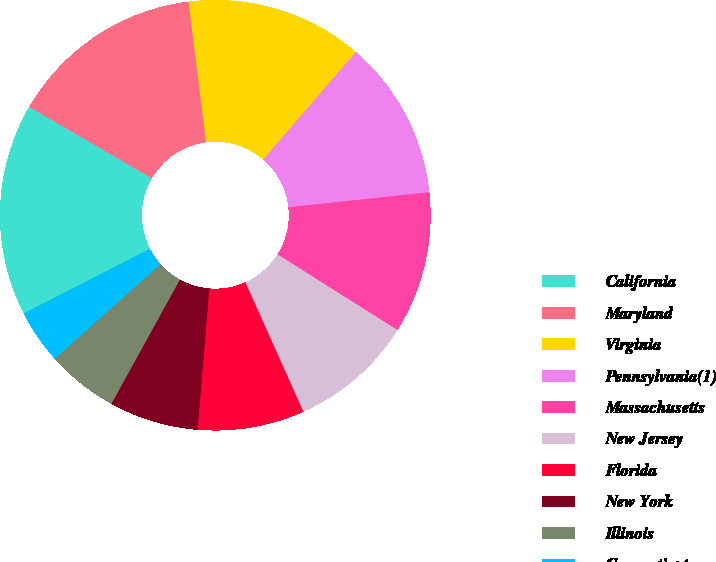<chart> <loc_0><loc_0><loc_500><loc_500><pie_chart><fcel>California<fcel>Maryland<fcel>Virginia<fcel>Pennsylvania(1)<fcel>Massachusetts<fcel>New Jersey<fcel>Florida<fcel>New York<fcel>Illinois<fcel>Connecticut<nl><fcel>15.94%<fcel>14.62%<fcel>13.3%<fcel>11.98%<fcel>10.66%<fcel>9.34%<fcel>8.02%<fcel>6.7%<fcel>5.38%<fcel>4.06%<nl></chart> 